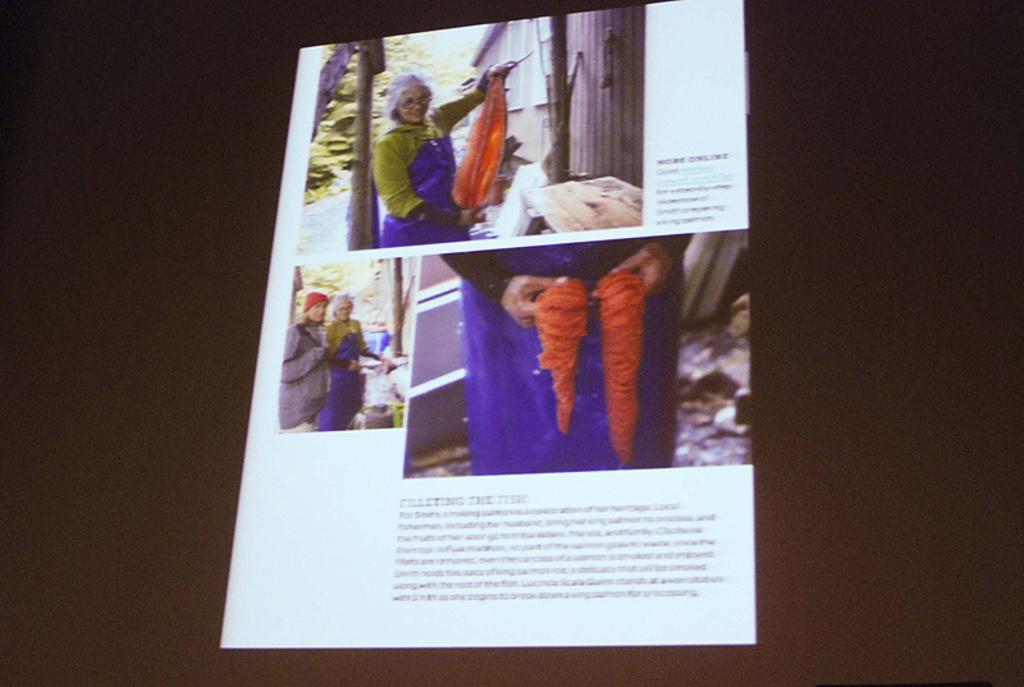Can you describe this image briefly? In this image, we can see a screen, on the screen, we can see some pictures and text written on it. In the background, we can see black color. 